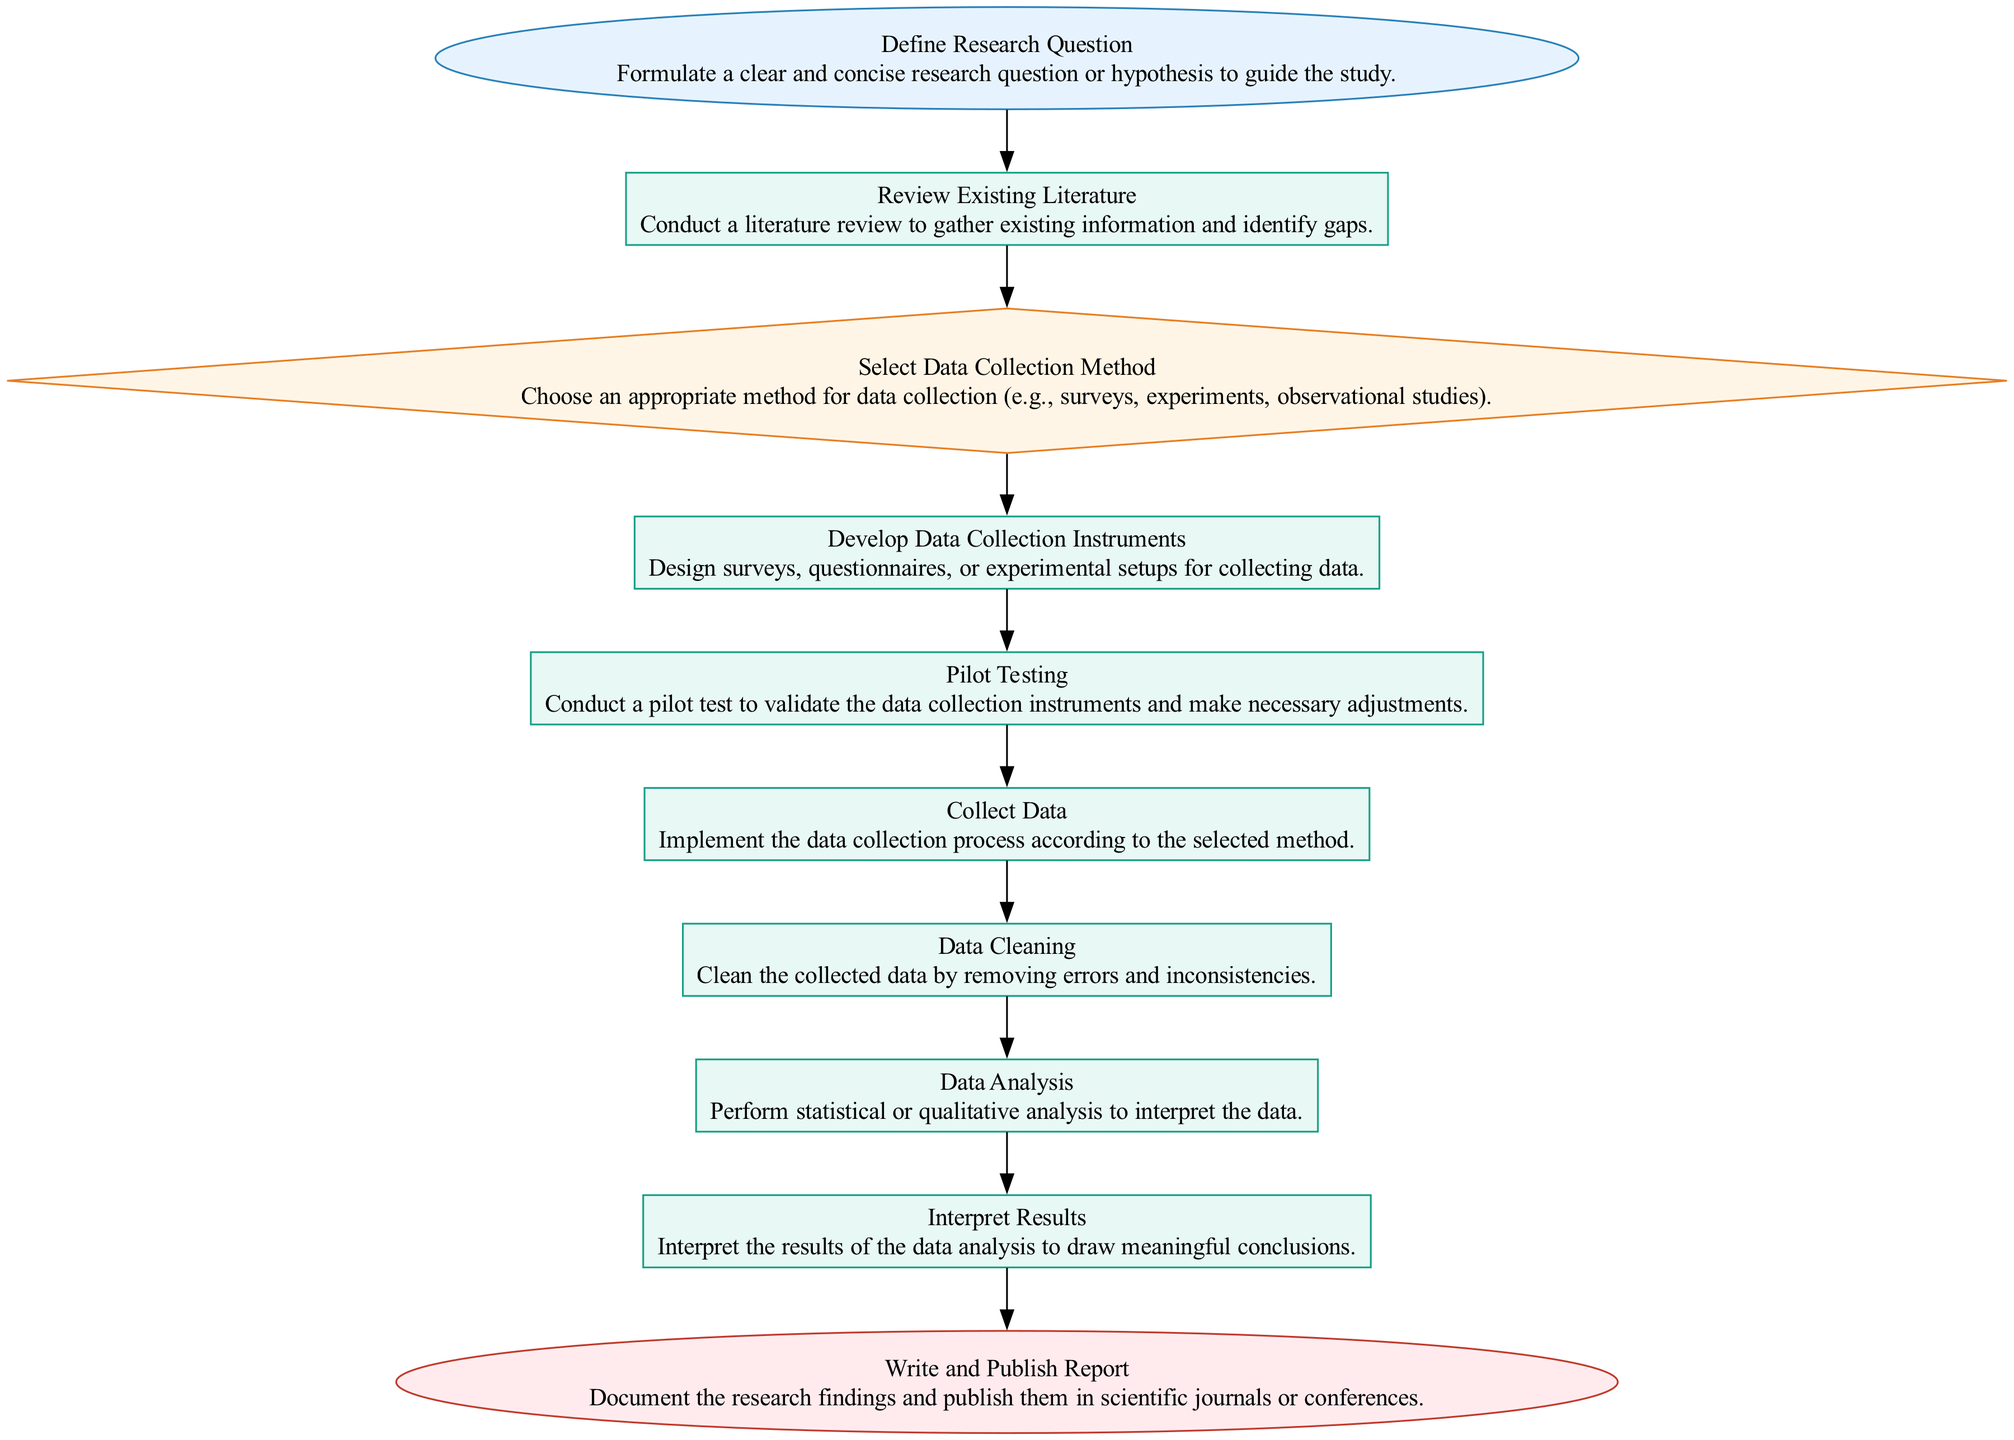What is the first step in the flowchart? The first step (Start node) in the flowchart is "Define Research Question", which indicates that formulating a research question is the initial action in the data collection and analysis procedure.
Answer: Define Research Question How many nodes are in the flowchart? By counting the specific elements in the flowchart, there are a total of ten nodes representing different stages of the data collection and analysis procedure.
Answer: Ten What type of node is "Data Analysis"? The node "Data Analysis" is identified as a Process type, indicating that it involves performing actions such as statistical or qualitative analysis on the collected data.
Answer: Process How many processes are there in total? The flowchart contains seven Process nodes: the steps "Review Existing Literature", "Develop Data Collection Instruments", "Pilot Testing", "Collect Data", "Data Cleaning", "Data Analysis", and "Interpret Results".
Answer: Seven Which node follows "Pilot Testing"? The node that follows "Pilot Testing" is "Collect Data", indicating that after testing the instruments, the next step is to implement the data collection process.
Answer: Collect Data What is the last step before publishing the report? The last step before publishing the report is "Interpret Results", which involves making sense of the analyzed data to draw conclusions that will be documented in the report.
Answer: Interpret Results What is the function of the "Select Data Collection Method" node? The "Select Data Collection Method" node serves as a Decision point, guiding the researcher to choose an appropriate technique for gathering data based on the specific requirements of the research study.
Answer: Decision What type of relationship exists between "Collect Data" and "Data Cleaning"? The relationship between "Collect Data" and "Data Cleaning" is sequential; "Data Cleaning" follows "Collect Data", indicating that once data is collected, it needs to be cleaned for further analysis.
Answer: Sequential What activity is suggested in the "Write and Publish Report" node? The activity suggested in the "Write and Publish Report" node is the documentation of research findings and the dissemination of those findings in scientific journals or conferences.
Answer: Document research findings 